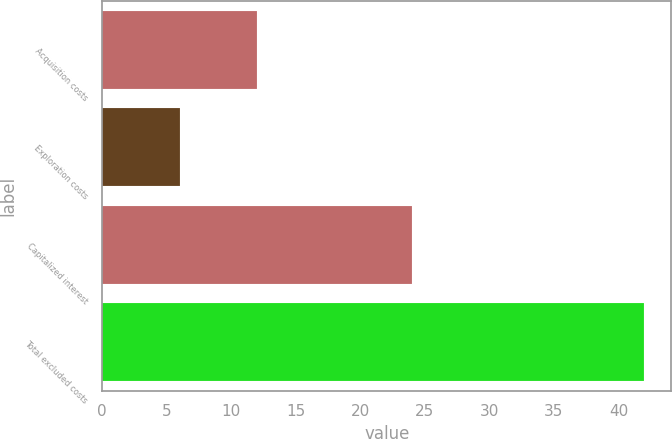<chart> <loc_0><loc_0><loc_500><loc_500><bar_chart><fcel>Acquisition costs<fcel>Exploration costs<fcel>Capitalized interest<fcel>Total excluded costs<nl><fcel>12<fcel>6<fcel>24<fcel>42<nl></chart> 